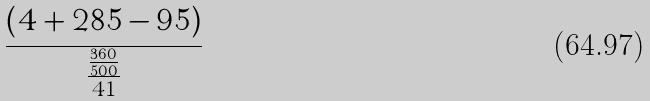<formula> <loc_0><loc_0><loc_500><loc_500>\frac { ( 4 + 2 8 5 - 9 5 ) } { \frac { \frac { 3 6 0 } { 5 0 0 } } { 4 1 } }</formula> 